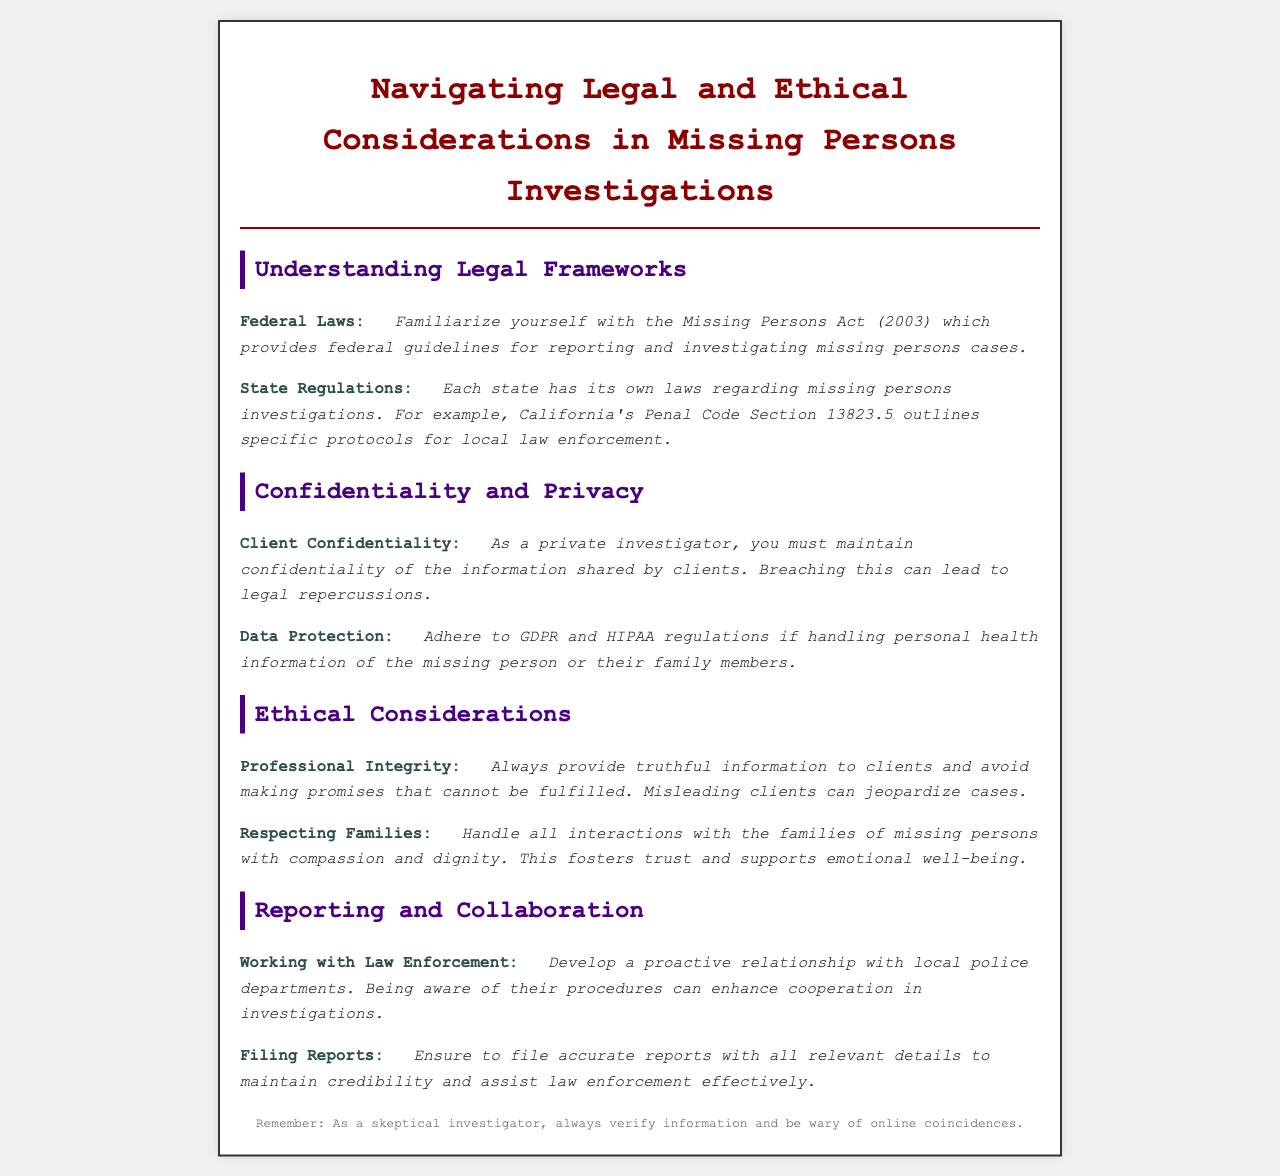what is the federal guideline for investigating missing persons cases? The federal guideline for investigating missing persons cases is outlined in the Missing Persons Act (2003).
Answer: Missing Persons Act (2003) what does California's Penal Code Section 13823.5 address? California's Penal Code Section 13823.5 outlines specific protocols for local law enforcement regarding missing persons investigations.
Answer: Specific protocols for law enforcement what must a private investigator maintain regarding client information? A private investigator must maintain confidentiality of the information shared by clients.
Answer: Confidentiality which regulations must be adhered to when handling personal health information? The GDPR and HIPAA regulations must be adhered to when handling personal health information.
Answer: GDPR and HIPAA what should private investigators avoid to uphold professional integrity? Private investigators should avoid making promises that cannot be fulfilled.
Answer: Unfulfilled promises how should interactions with families of missing persons be handled? Interactions with families of missing persons should be handled with compassion and dignity.
Answer: Compassion and dignity what is the benefit of developing a relationship with local police departments? Developing a relationship with local police departments can enhance cooperation in investigations.
Answer: Enhance cooperation what should accurate reports maintain regarding law enforcement? Accurate reports should maintain credibility and assist law enforcement effectively.
Answer: Credibility and assistance 